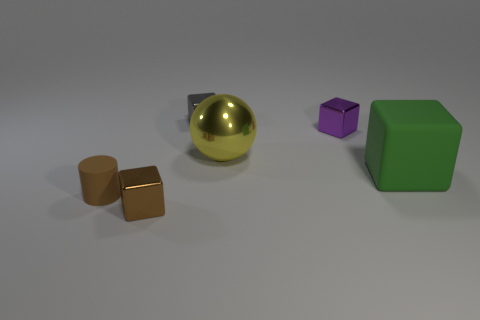Do the tiny brown cylinder and the purple block have the same material?
Ensure brevity in your answer.  No. Is there a tiny purple shiny object of the same shape as the small gray metallic object?
Make the answer very short. Yes. Do the rubber thing to the left of the brown metallic block and the large cube have the same color?
Offer a very short reply. No. Is the size of the brown metal thing that is on the left side of the big metallic ball the same as the block that is behind the purple object?
Ensure brevity in your answer.  Yes. What is the size of the yellow ball that is the same material as the purple object?
Provide a short and direct response. Large. How many objects are in front of the tiny purple cube and left of the yellow metal object?
Provide a succinct answer. 2. How many objects are either big gray matte cubes or tiny blocks that are in front of the tiny matte object?
Your answer should be compact. 1. There is a small metallic object that is the same color as the rubber cylinder; what shape is it?
Your answer should be very brief. Cube. There is a small metal cube that is in front of the yellow ball; what color is it?
Offer a terse response. Brown. How many things are either small things that are behind the large matte thing or red cubes?
Offer a terse response. 2. 